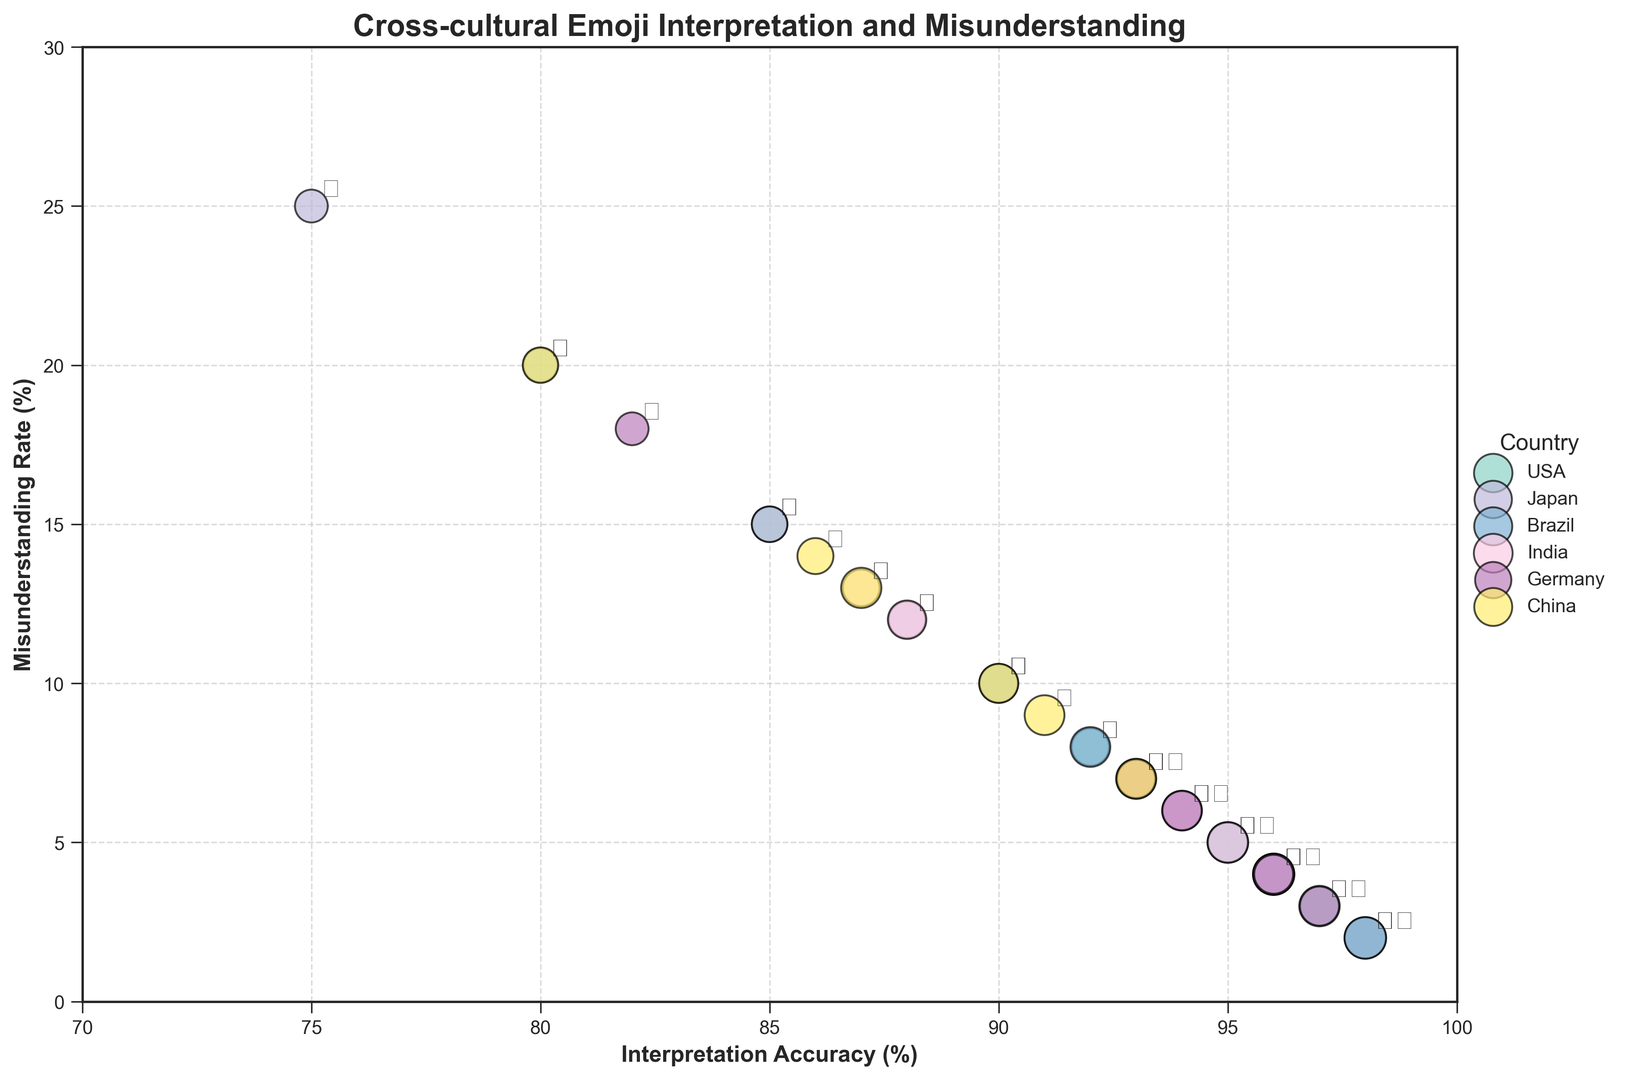Which country has the highest interpretation accuracy for the 😊 emoji? Look for the data points labeled with the 😊 emoji and compare their positions on the x-axis. The USA has the highest interpretation accuracy as it is the furthest to the right.
Answer: USA Which emoji has the lowest misunderstanding rate in Japan? Focus on the data points for Japan and compare their positions on the y-axis. The emoji with the lowest point on the y-axis is 🙏.
Answer: 🙏 What is the sum of the interpretation accuracy percentages for the 😂 emoji in the USA and Brazil? Identify the interpretation accuracy percentages for the 😂 emoji in the USA (96%) and Brazil (95%) and sum them: 96 + 95 = 191.
Answer: 191 Which country has the largest bubble for the 🤔 emoji, and what does this represent? Look at the bubbles for the 🤔 emoji and compare their sizes. The largest bubble for the 🤔 emoji is in the USA, indicating the highest usage frequency.
Answer: USA (highest usage frequency) How does the misunderstanding rate for the 👍 emoji in Japan compare to that in China? Find the y-axis values for the 👍 emoji in Japan (25%) and China (20%), and note that Japan's rate is higher.
Answer: Japan has a higher misunderstanding rate Compare the interpretation accuracy for the 😊 emoji between the USA and Germany; which country is higher? Locate the data points for the 😊 emoji in the USA and Germany and compare their x-axis positions. The USA (95%) is higher than Germany (93%).
Answer: USA Calculate the average misunderstanding rate for the ❤️ emoji across all countries presented. Add the misunderstanding rates for the ❤️ emoji across all countries: 3 (USA) + 6 (Japan) + 2 (Brazil) + 5 (India) + 4 (Germany) + 7 (China) = 27. Divide by the number of countries (6): 27/6 = 4.5.
Answer: 4.5 Which emoji has the highest misunderstanding rate in India? Look at the data points for India and compare their positions on the y-axis. The emoji with the highest point is 😊 (12%).
Answer: 😊 What is the difference in usage frequency of the 🙏 emoji between Japan and India? Identify the usage frequencies for the 🙏 emoji in Japan (95) and India (92). Subtract India's value from Japan's: 95 - 92 = 3.
Answer: 3 Among the countries compared, which has the least variation in misunderstanding rates across all emojis? Observe the spread of data points for each country. The USA shows minimal variation, with misunderstanding rates between 2% and 15%.
Answer: USA 